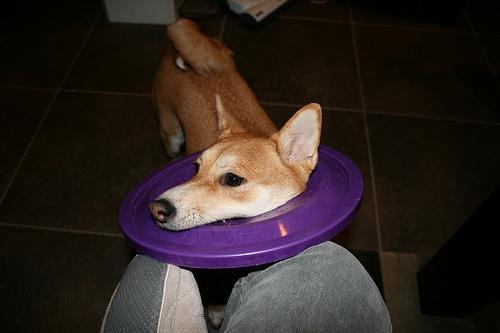How many dogs are there?
Give a very brief answer. 1. 